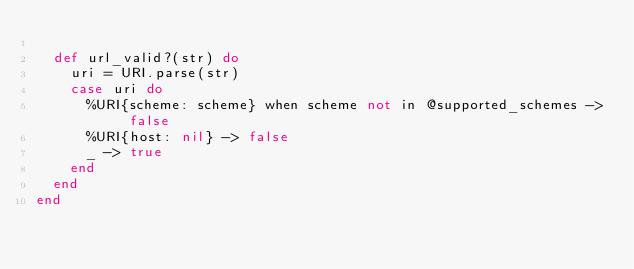<code> <loc_0><loc_0><loc_500><loc_500><_Elixir_>
  def url_valid?(str) do
    uri = URI.parse(str)
    case uri do
      %URI{scheme: scheme} when scheme not in @supported_schemes -> false
      %URI{host: nil} -> false
      _ -> true
    end
  end
end
</code> 